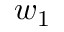Convert formula to latex. <formula><loc_0><loc_0><loc_500><loc_500>w _ { 1 }</formula> 